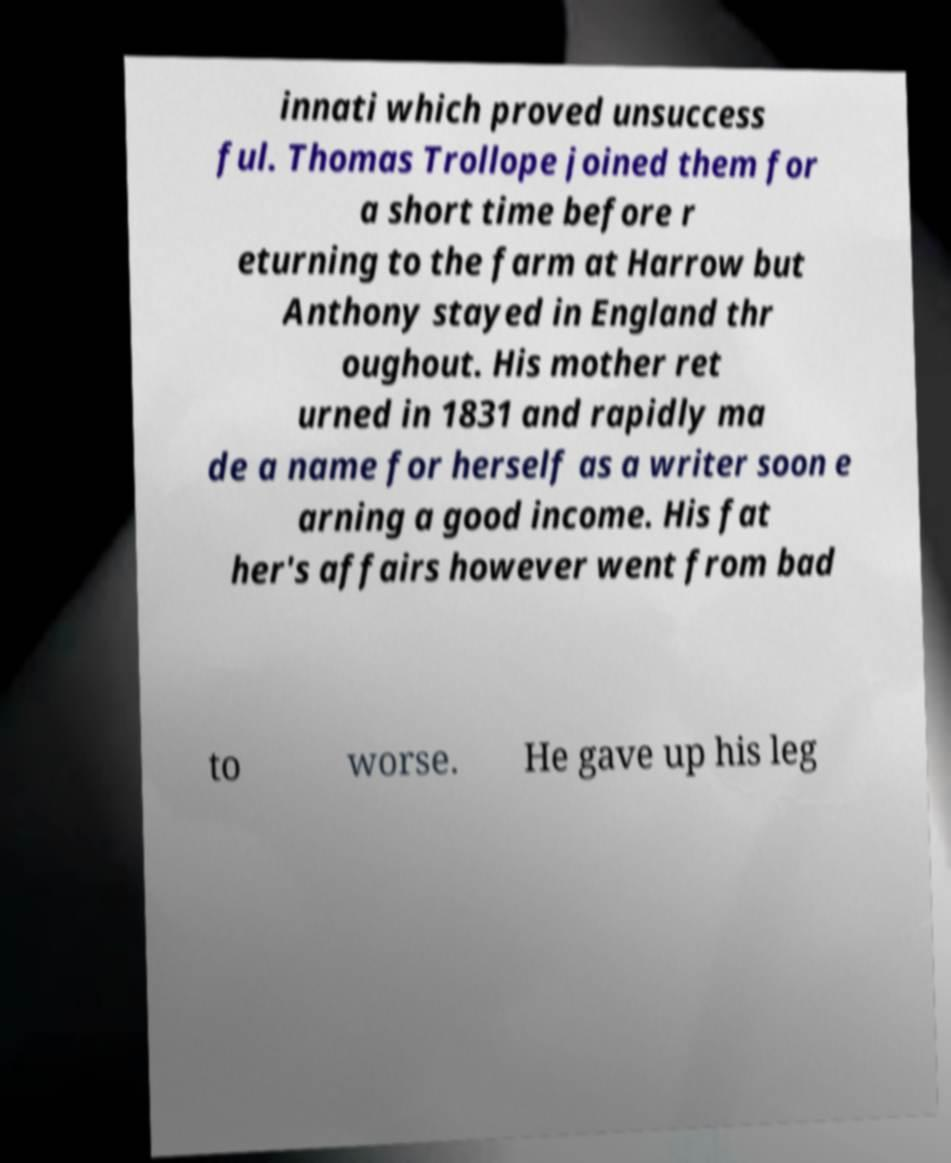I need the written content from this picture converted into text. Can you do that? innati which proved unsuccess ful. Thomas Trollope joined them for a short time before r eturning to the farm at Harrow but Anthony stayed in England thr oughout. His mother ret urned in 1831 and rapidly ma de a name for herself as a writer soon e arning a good income. His fat her's affairs however went from bad to worse. He gave up his leg 